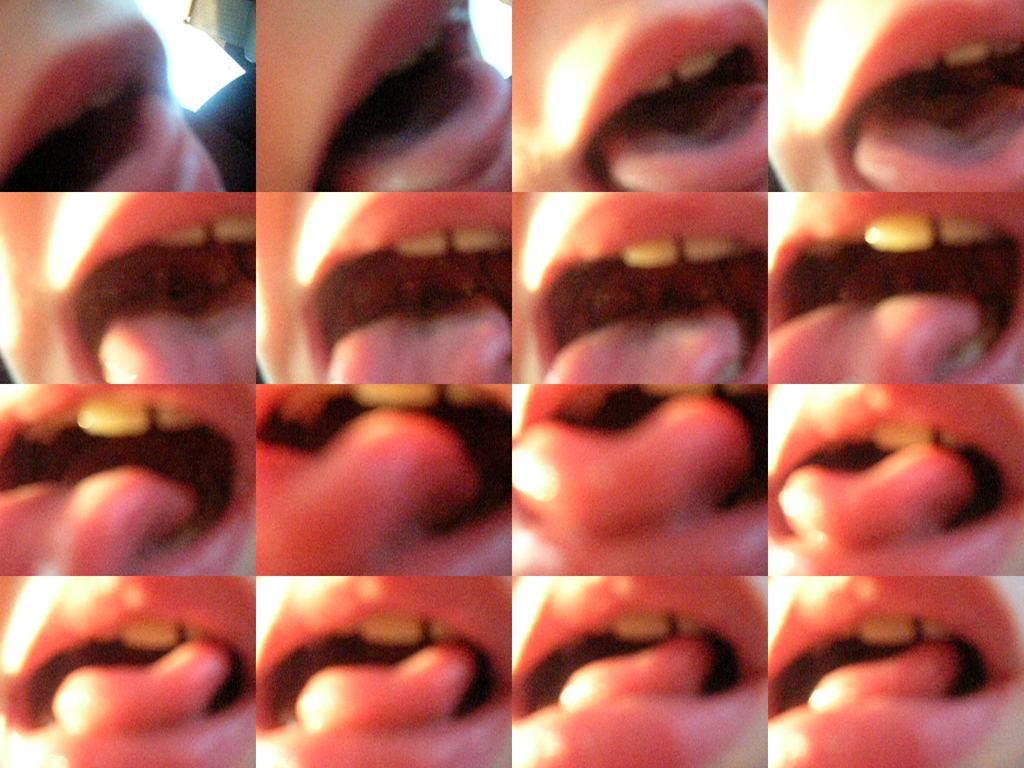What is the main subject of the image? The main subject of the image is collages of a person's mouth. Can you describe the collages in more detail? Unfortunately, the facts provided do not give any further details about the collages. Are there any other elements in the image besides the collages? The facts provided do not mention any other elements in the image. What type of force is being exerted on the ocean in the image? There is no ocean present in the image, so it is not possible to determine if any force is being exerted on it. 